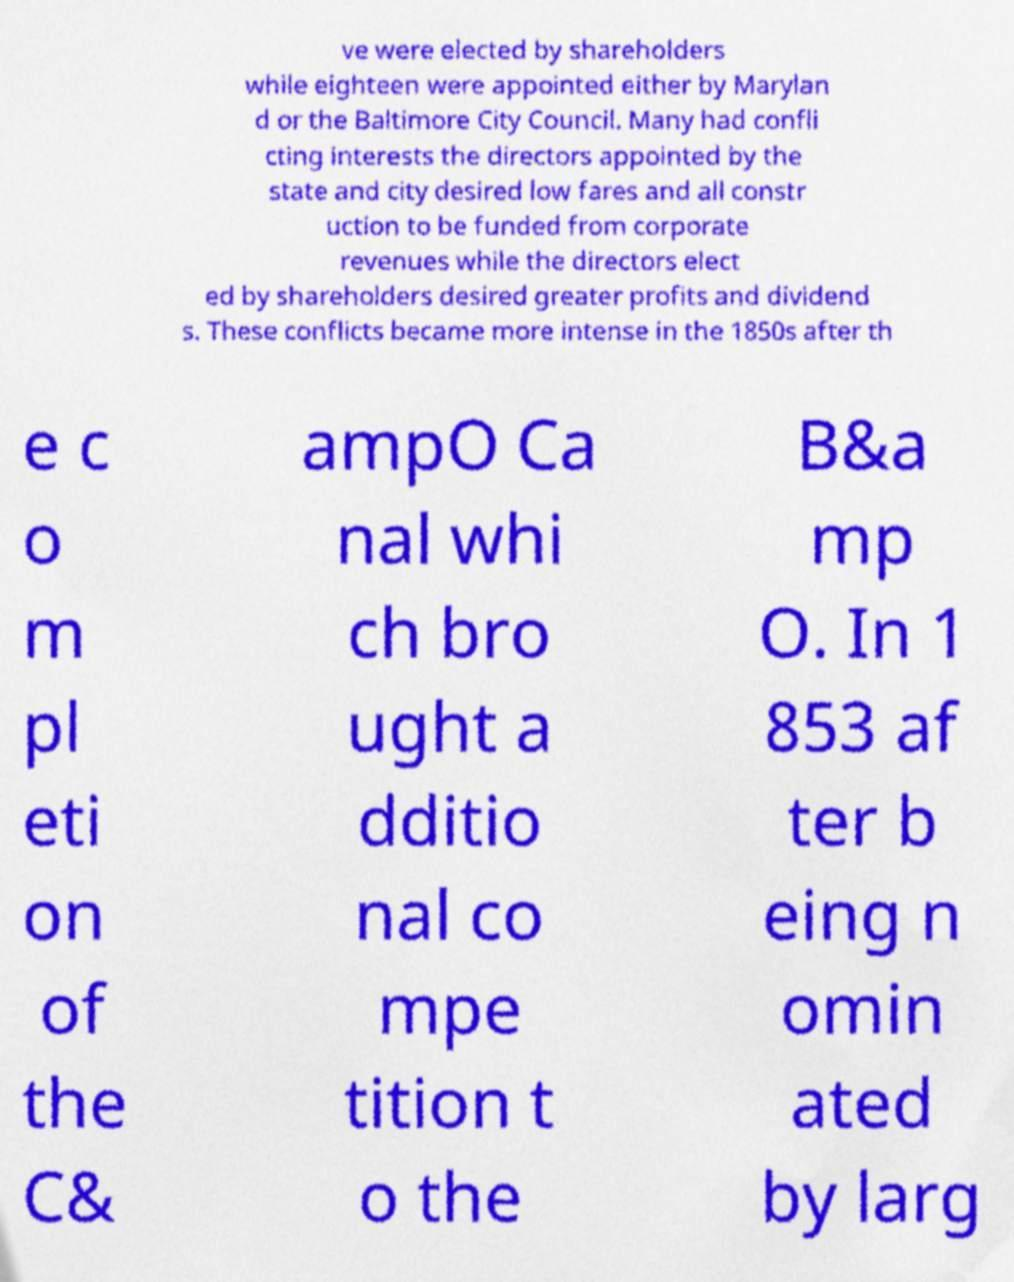For documentation purposes, I need the text within this image transcribed. Could you provide that? ve were elected by shareholders while eighteen were appointed either by Marylan d or the Baltimore City Council. Many had confli cting interests the directors appointed by the state and city desired low fares and all constr uction to be funded from corporate revenues while the directors elect ed by shareholders desired greater profits and dividend s. These conflicts became more intense in the 1850s after th e c o m pl eti on of the C& ampO Ca nal whi ch bro ught a dditio nal co mpe tition t o the B&a mp O. In 1 853 af ter b eing n omin ated by larg 